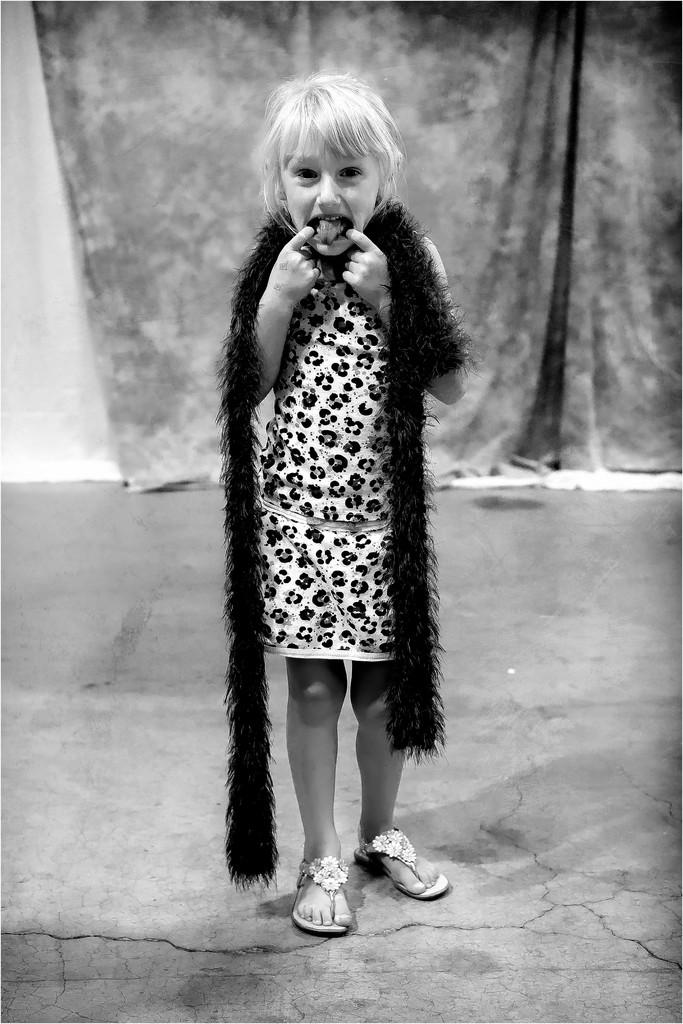What is the color scheme of the image? The image is black and white. Who or what is the main subject in the image? There is a girl standing in the center of the image. What can be seen in the background of the image? There is a curtain in the background of the image. What is visible at the bottom of the image? The floor is visible at the bottom of the image. What type of mark can be seen on the girl's face in the image? There is no mark visible on the girl's face in the image. How many geese are present in the image? There are no geese present in the image. 